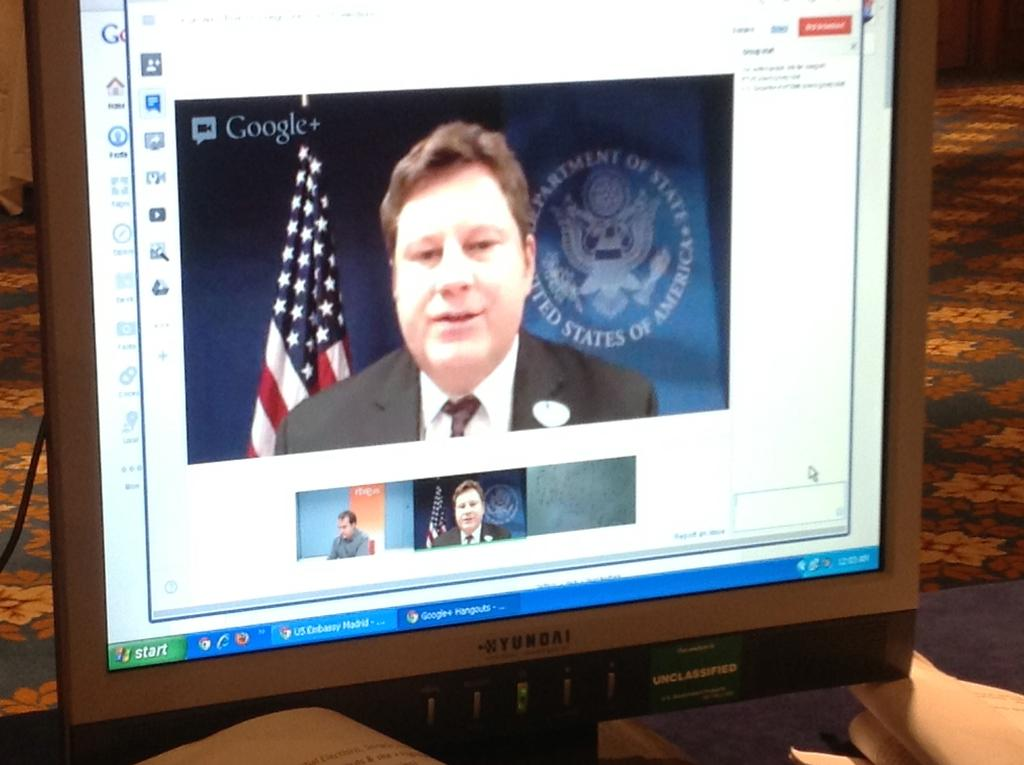Provide a one-sentence caption for the provided image. Yundai computer shows a video of a man talking. 